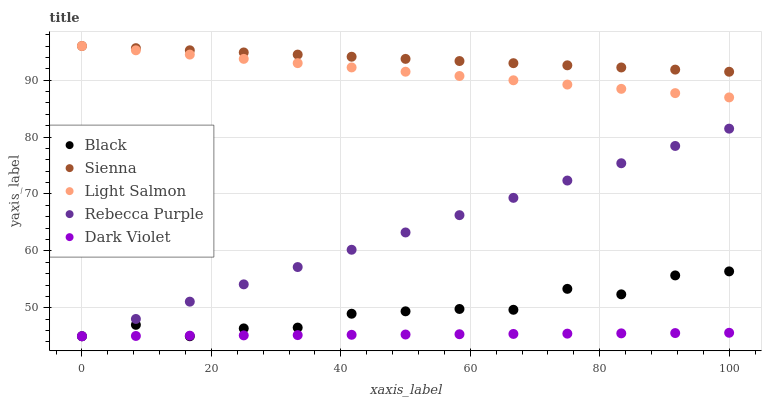Does Dark Violet have the minimum area under the curve?
Answer yes or no. Yes. Does Sienna have the maximum area under the curve?
Answer yes or no. Yes. Does Light Salmon have the minimum area under the curve?
Answer yes or no. No. Does Light Salmon have the maximum area under the curve?
Answer yes or no. No. Is Dark Violet the smoothest?
Answer yes or no. Yes. Is Black the roughest?
Answer yes or no. Yes. Is Light Salmon the smoothest?
Answer yes or no. No. Is Light Salmon the roughest?
Answer yes or no. No. Does Black have the lowest value?
Answer yes or no. Yes. Does Light Salmon have the lowest value?
Answer yes or no. No. Does Light Salmon have the highest value?
Answer yes or no. Yes. Does Black have the highest value?
Answer yes or no. No. Is Dark Violet less than Light Salmon?
Answer yes or no. Yes. Is Sienna greater than Dark Violet?
Answer yes or no. Yes. Does Sienna intersect Light Salmon?
Answer yes or no. Yes. Is Sienna less than Light Salmon?
Answer yes or no. No. Is Sienna greater than Light Salmon?
Answer yes or no. No. Does Dark Violet intersect Light Salmon?
Answer yes or no. No. 